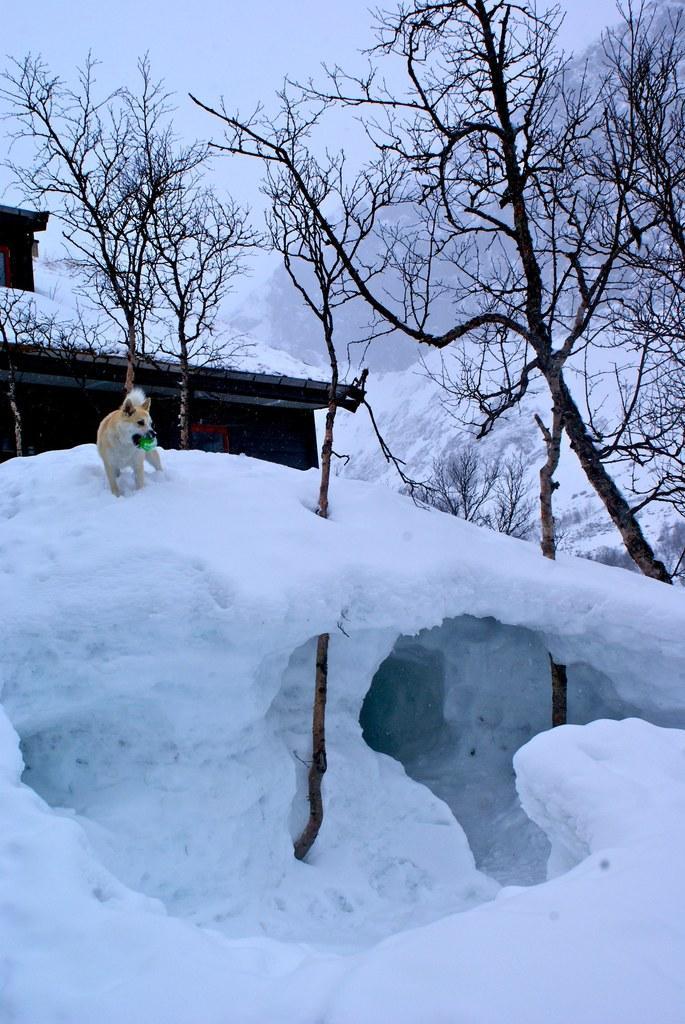Can you describe this image briefly? In this image I can see the dog on the snow. The dog is in white and brown color. In the background I can see the house, many trees and sky. 